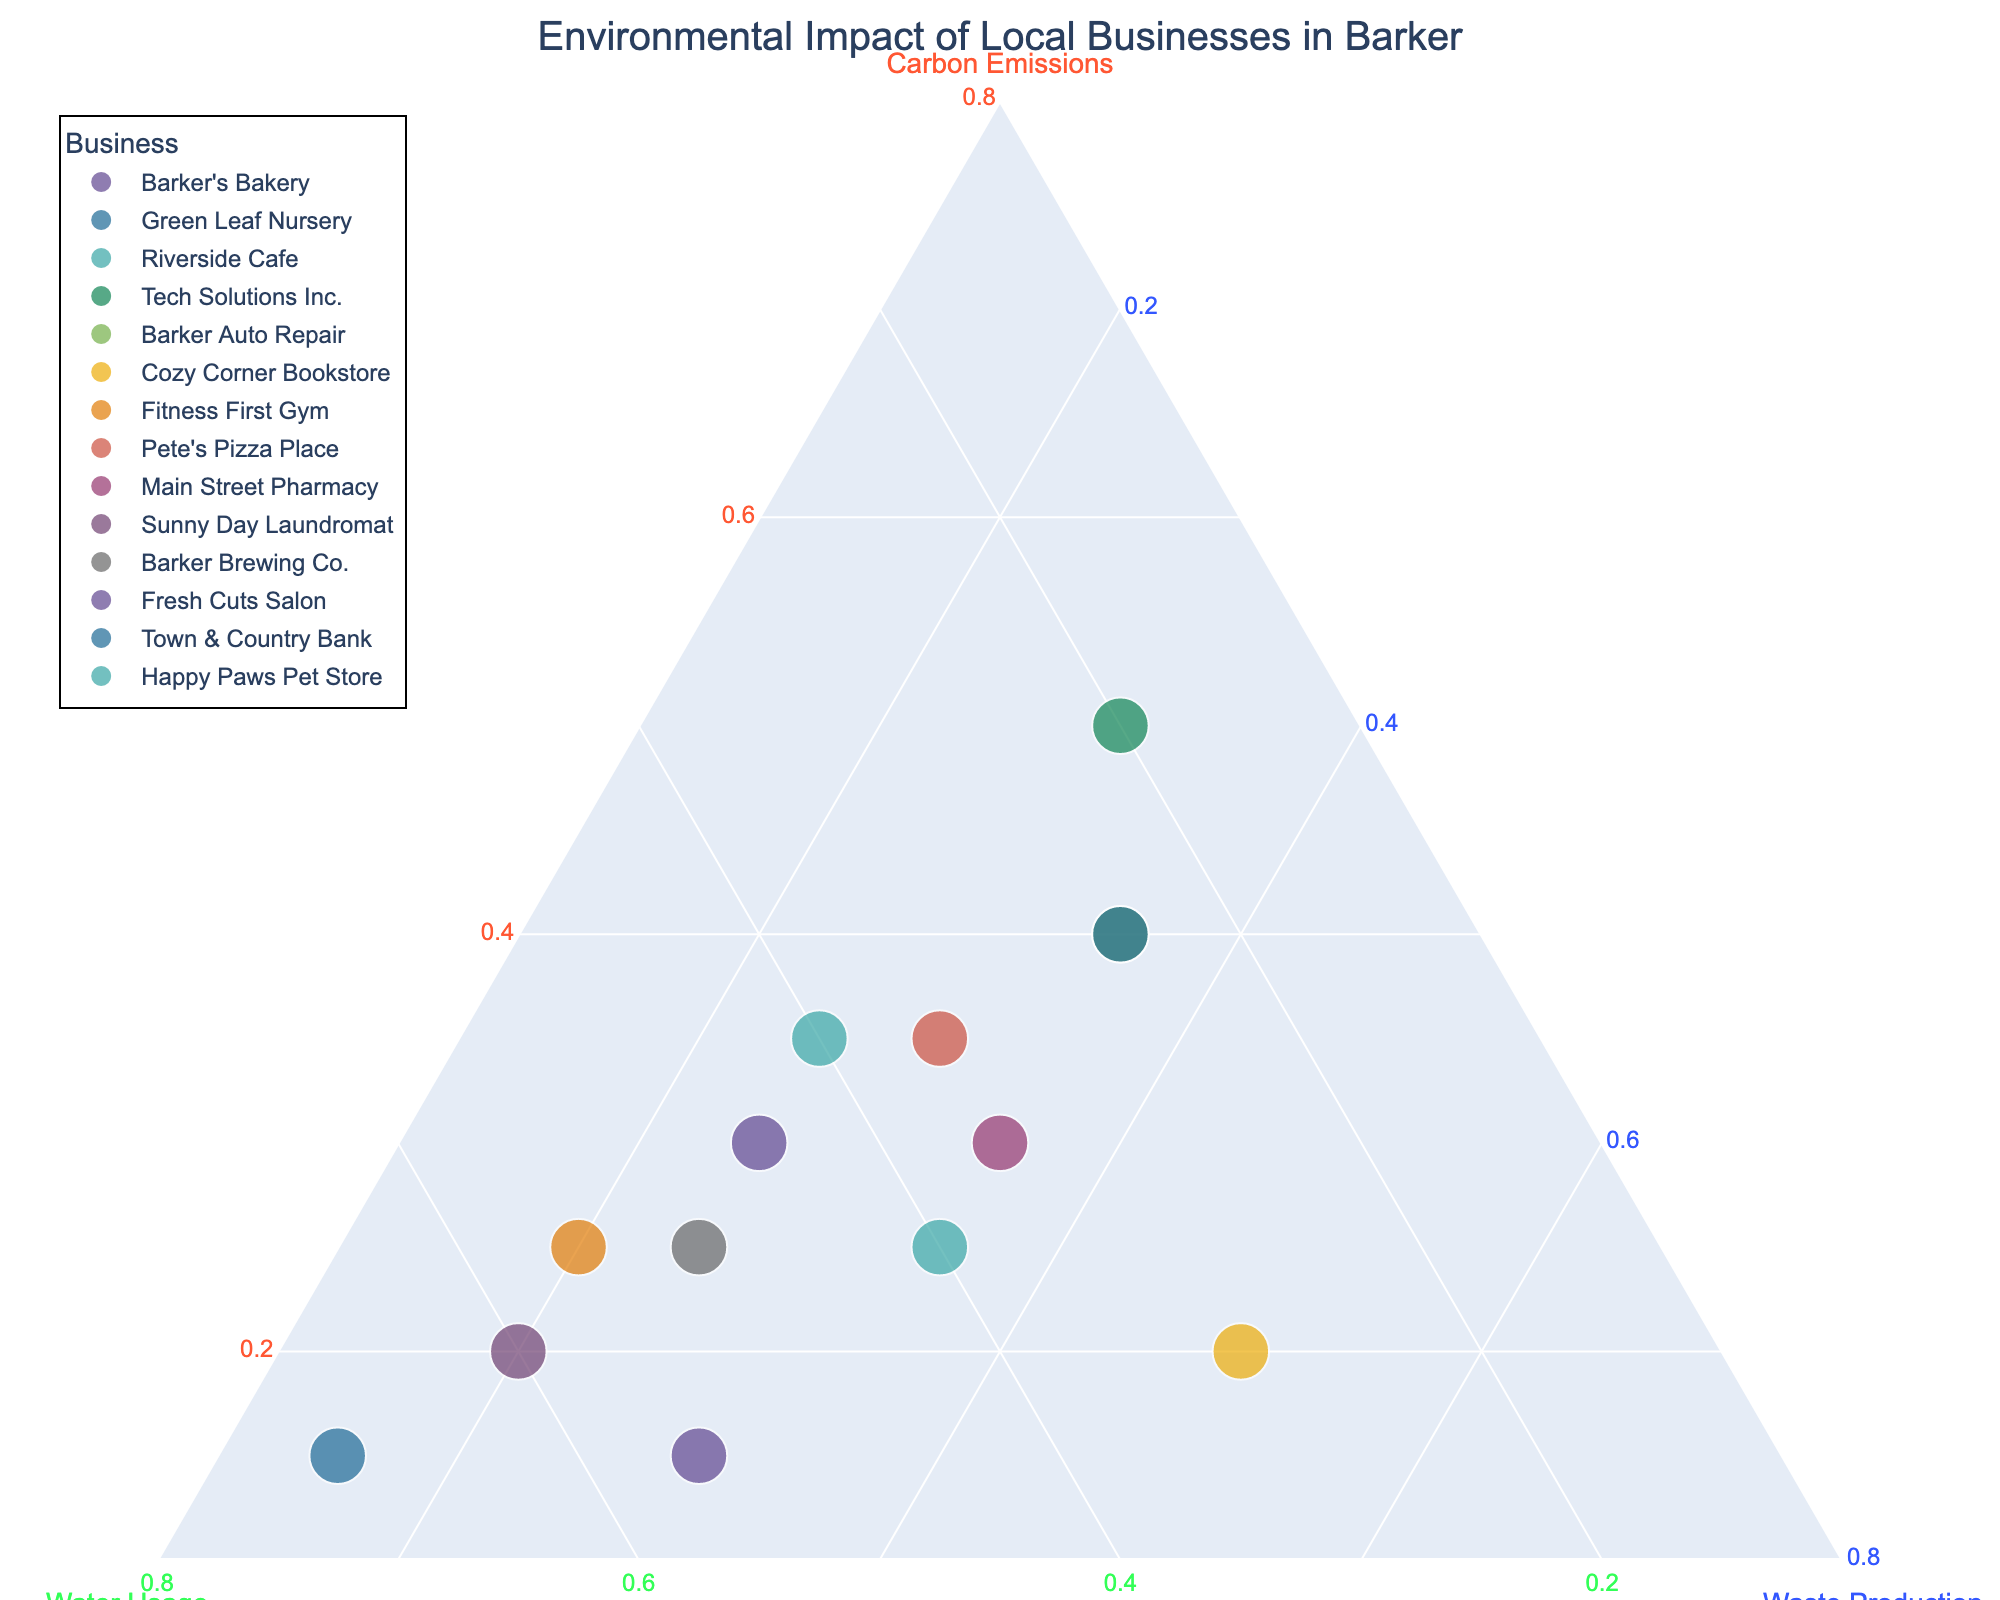What is the title of the ternary plot? The title is prominently displayed at the top of the chart. By reading, it directly gives us the title.
Answer: Environmental Impact of Local Businesses in Barker What are the three environmental factors measured in this ternary plot? The axis titles on the ternary plot specify the three factors being analyzed. They are Carbon Emissions, Water Usage, and Waste Production as per the data and plot axes.
Answer: Carbon Emissions, Water Usage, Waste Production Which business has the highest carbon emissions? By observing which point is closest to the Carbon Emissions axis, we find that Tech Solutions Inc is the highest.
Answer: Tech Solutions Inc What is the average water usage of Riverside Cafe and Cozy Corner Bookstore combined? Riverside Cafe's water usage is 40% and Cozy Corner Bookstore's water usage is 30%. Adding these percentages gives 70%, and the average is 70% / 2 = 35%.
Answer: 35% Which business has an equal proportion of carbon emissions and waste production? Sunny Day Laundromat has 20% Carbon Emissions and 20% Waste Production, indicating an equal proportion.
Answer: Sunny Day Laundromat What is the difference in carbon emissions between Barker's Bakery and Pete's Pizza Place? Barker's Bakery has 30% carbon emissions, and Pete's Pizza Place has 35%. The difference is 35% - 30% = 5%.
Answer: 5% Which two businesses have exactly the same environmental impact ratios? Barker Auto Repair and Town & Country Bank both have an identical environmental impact with 40% carbon emissions, 25% water usage, and 35% waste production.
Answer: Barker Auto Repair and Town & Country Bank Which business prioritizes water usage the most? The business closest to the Water Usage axis represents the highest value. Green Leaf Nursery has the highest water usage at 70%.
Answer: Green Leaf Nursery In terms of balanced environmental impact (similar values across all three metrics), which business stands out? Main Street Pharmacy is positioned closest to the center of the ternary plot, suggesting a balanced environmental impact with nearly equal values in all three categories (30% carbon emissions, 35% water usage, 35% waste production).
Answer: Main Street Pharmacy 